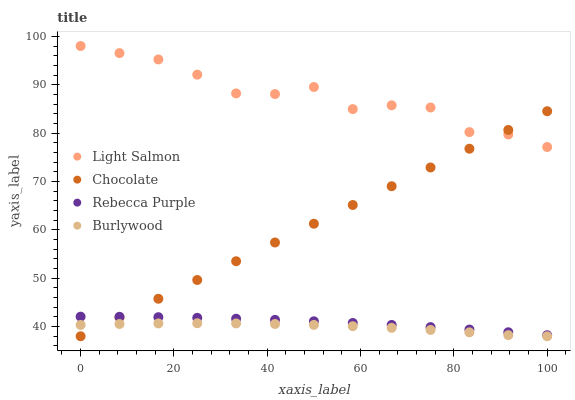Does Burlywood have the minimum area under the curve?
Answer yes or no. Yes. Does Light Salmon have the maximum area under the curve?
Answer yes or no. Yes. Does Rebecca Purple have the minimum area under the curve?
Answer yes or no. No. Does Rebecca Purple have the maximum area under the curve?
Answer yes or no. No. Is Chocolate the smoothest?
Answer yes or no. Yes. Is Light Salmon the roughest?
Answer yes or no. Yes. Is Rebecca Purple the smoothest?
Answer yes or no. No. Is Rebecca Purple the roughest?
Answer yes or no. No. Does Burlywood have the lowest value?
Answer yes or no. Yes. Does Rebecca Purple have the lowest value?
Answer yes or no. No. Does Light Salmon have the highest value?
Answer yes or no. Yes. Does Rebecca Purple have the highest value?
Answer yes or no. No. Is Burlywood less than Light Salmon?
Answer yes or no. Yes. Is Rebecca Purple greater than Burlywood?
Answer yes or no. Yes. Does Light Salmon intersect Chocolate?
Answer yes or no. Yes. Is Light Salmon less than Chocolate?
Answer yes or no. No. Is Light Salmon greater than Chocolate?
Answer yes or no. No. Does Burlywood intersect Light Salmon?
Answer yes or no. No. 